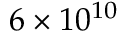Convert formula to latex. <formula><loc_0><loc_0><loc_500><loc_500>6 \times 1 0 ^ { 1 0 }</formula> 